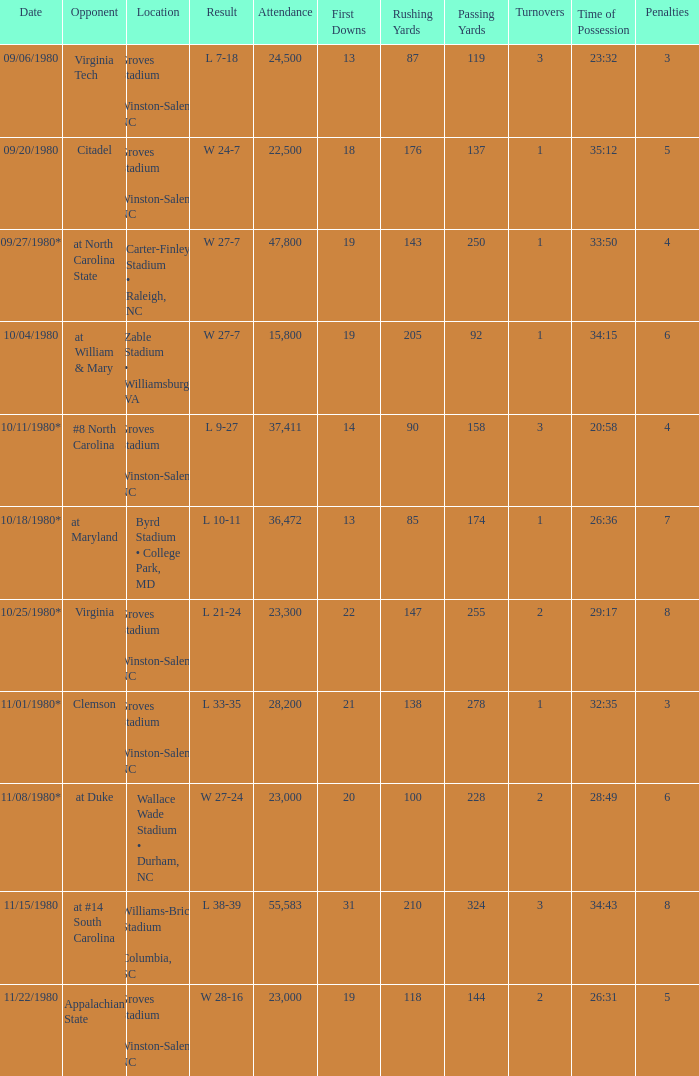How many people attended when Wake Forest played Virginia Tech? 24500.0. 